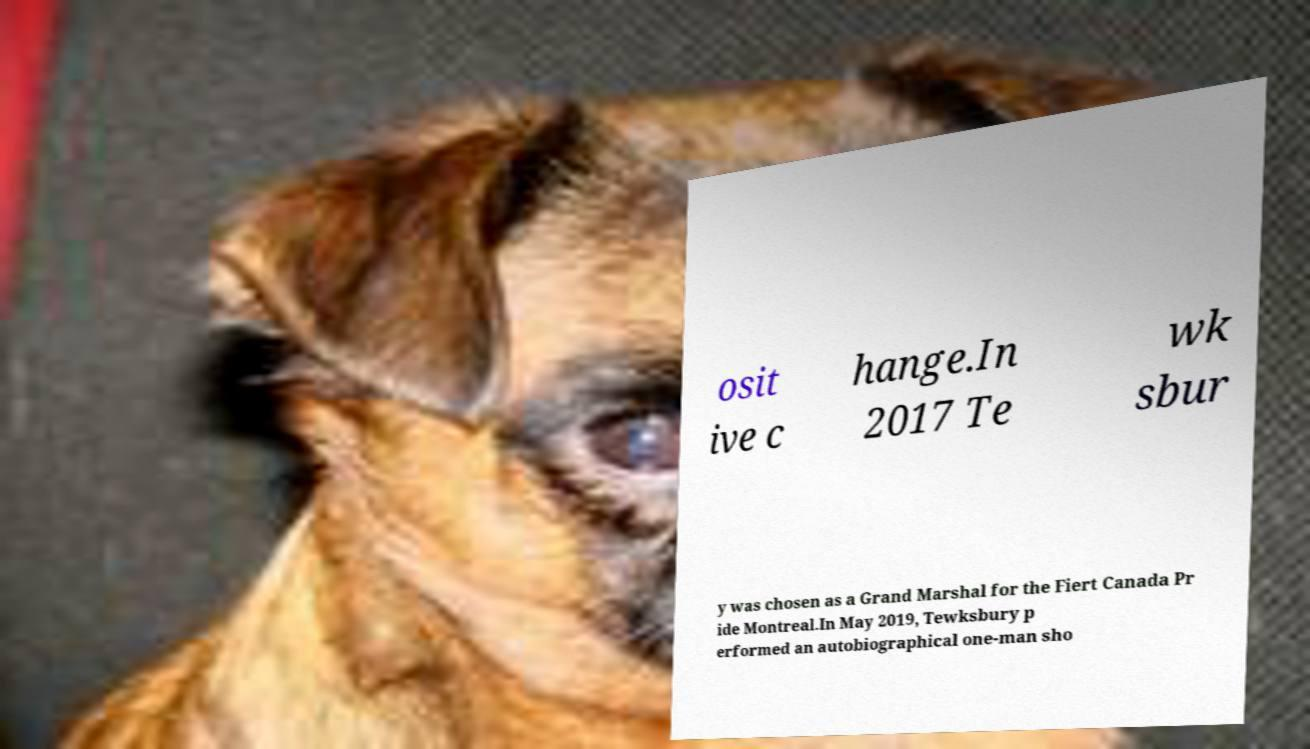For documentation purposes, I need the text within this image transcribed. Could you provide that? osit ive c hange.In 2017 Te wk sbur y was chosen as a Grand Marshal for the Fiert Canada Pr ide Montreal.In May 2019, Tewksbury p erformed an autobiographical one-man sho 